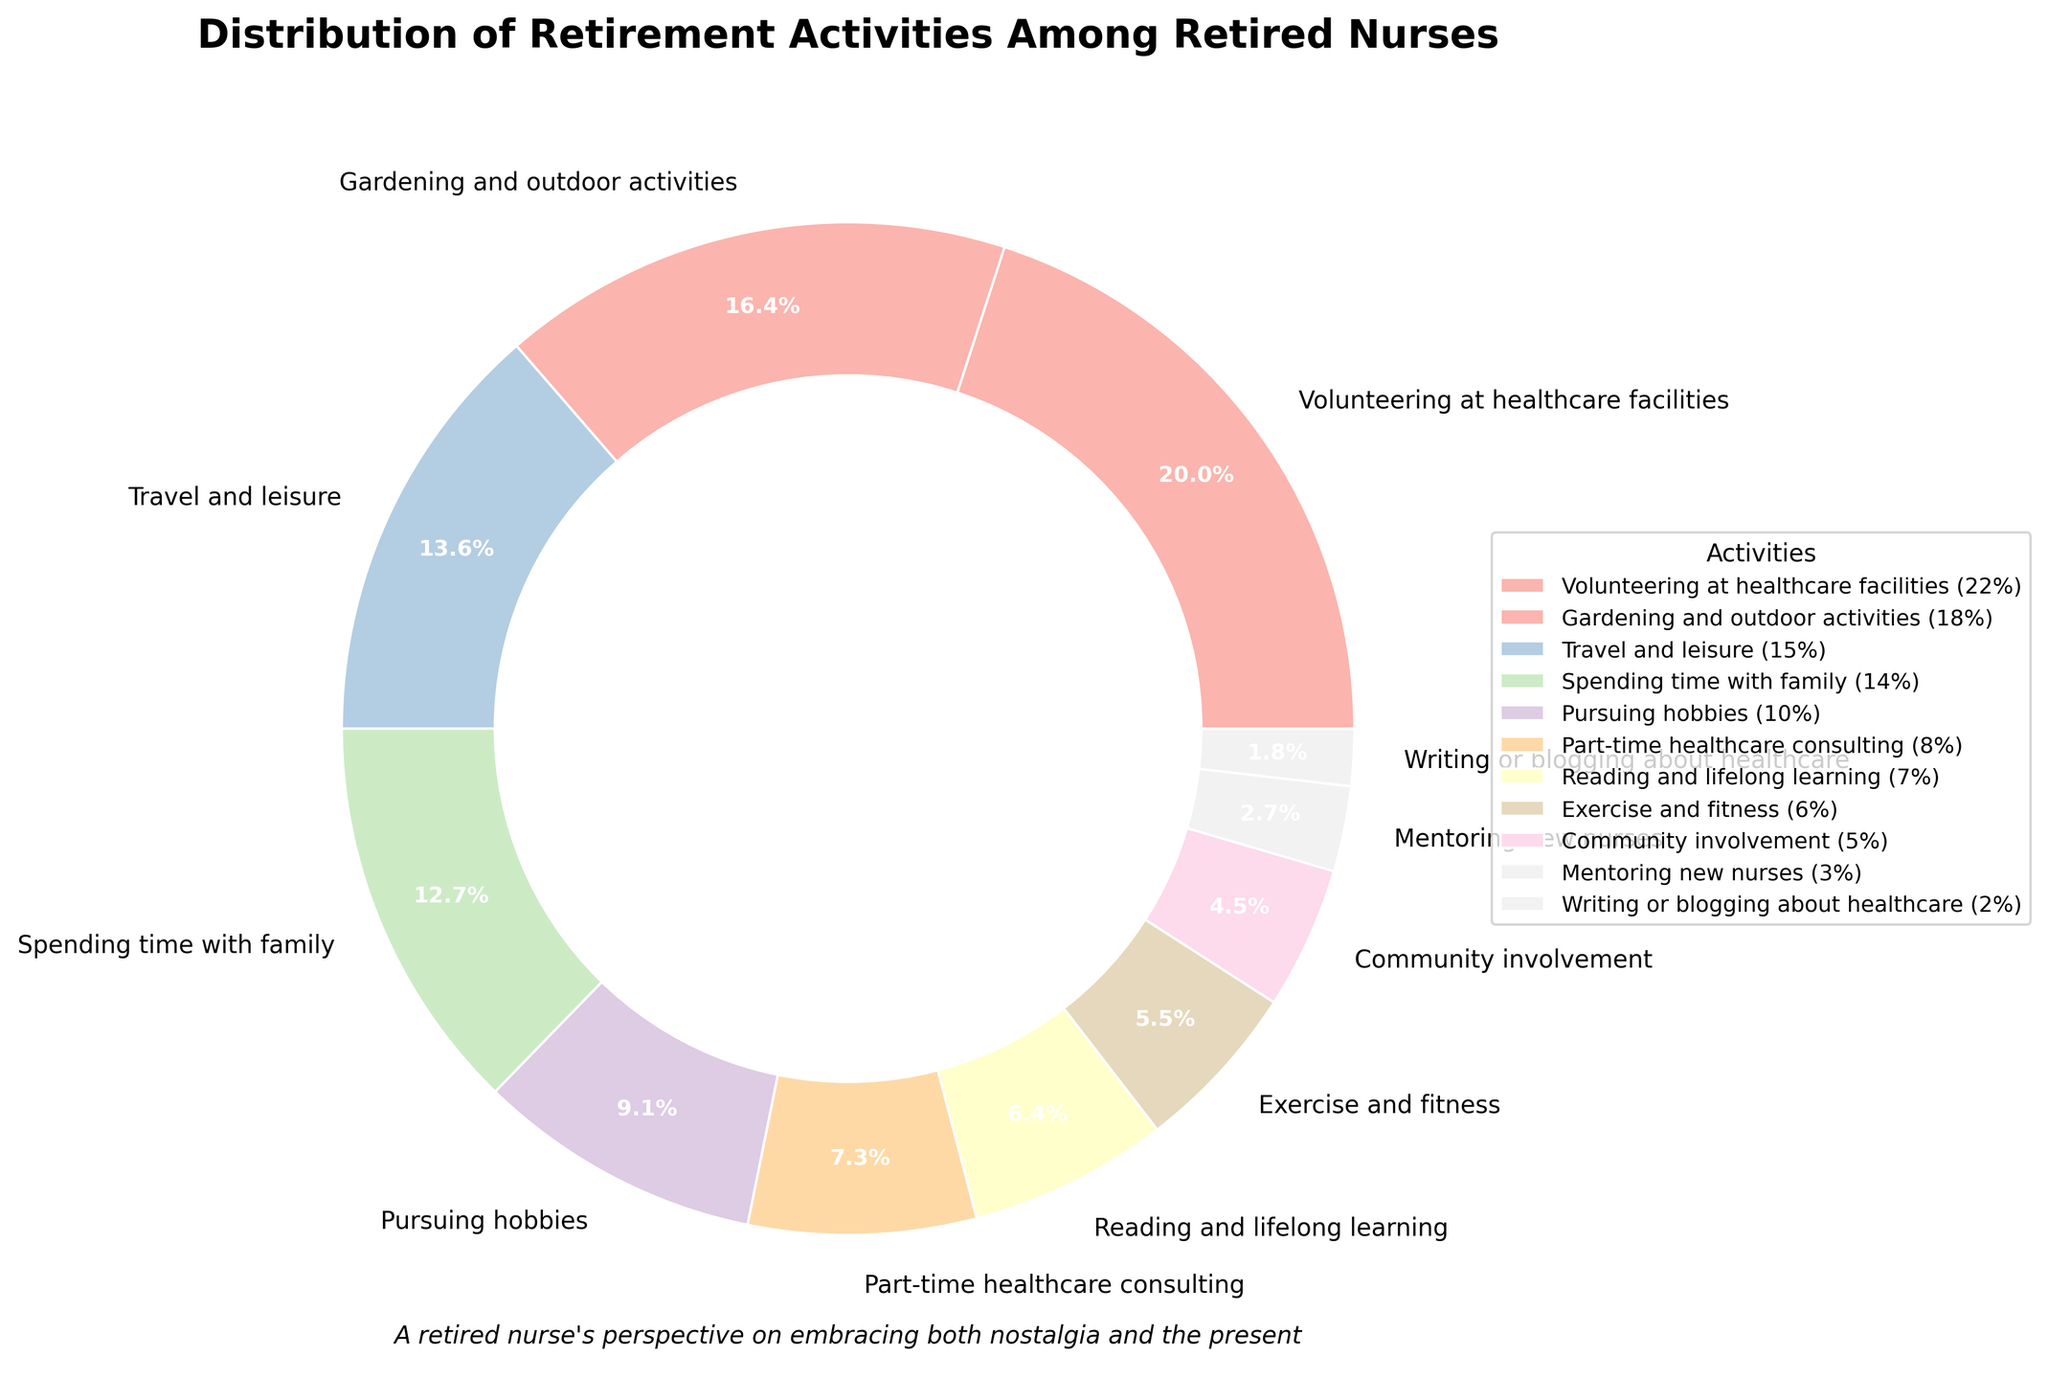what percentage of retired nurses engage in volunteering at healthcare facilities? The slice representing "Volunteering at healthcare facilities" indicates its percentage as 22%.
Answer: 22% which activity has the lowest percentage of participation among retired nurses? By observing the pie chart slices and the legend, "Writing or blogging about healthcare" has the smallest slice, representing 2%.
Answer: Writing or blogging about healthcare how much greater is the percentage of those participating in gardening and outdoor activities compared to reading and lifelong learning? The slice for "Gardening and outdoor activities" represents 18%, and "Reading and lifelong learning" is 7%. The difference is calculated as 18% - 7%.
Answer: 11% what fraction of retired nurses spend their time on exercise and fitness? The slice for "Exercise and fitness" represents 6% of the total activities. This can be understood as 6 out of 100 or simply 6%.
Answer: 6% which activities have a combined percentage that is equal to or greater than 25%? The percentage of "Volunteering at healthcare facilities" is 22%, and "Gardening and outdoor activities" is 18%. Individually, both are less than 25%, but their sum (22% + 18%) is 40%, which is greater than 25%.
Answer: Volunteering at healthcare facilities, Gardening and outdoor activities how does the percentage of retired nurses involved in part-time healthcare consulting compare to those mentoring new nurses? The slice for "Part-time healthcare consulting" represents 8%, while the slice for "Mentoring new nurses" is 3%. Part-time healthcare consulting has a higher percentage.
Answer: Part-time healthcare consulting what percentage of retired nurses engage in travel and leisure activities? The slice indicating "Travel and leisure" shows that 15% of the retired nurses partake in these activities.
Answer: 15% which activity has double the participation in comparison to community involvement? The "Community involvement" slice shows 5% participation. Doubling this gives 10%, matching the slice for "Pursuing hobbies" at 10%.
Answer: Pursuing hobbies what is the combined percentage for reading and lifelong learning, and writing or blogging about healthcare? The percentage for "Reading and lifelong learning" is 7%, while "Writing or blogging about healthcare" is 2%. Their combined percentage is calculated as 7% + 2%.
Answer: 9% what activity lies between spending time with family and pursuing hobbies in terms of percentage? Observing the chart, "Spending time with family" is 14%, and "Pursuing hobbies" is 10%. The activity "Travel and leisure" lies between these two percentages at 15%.
Answer: Travel and leisure 